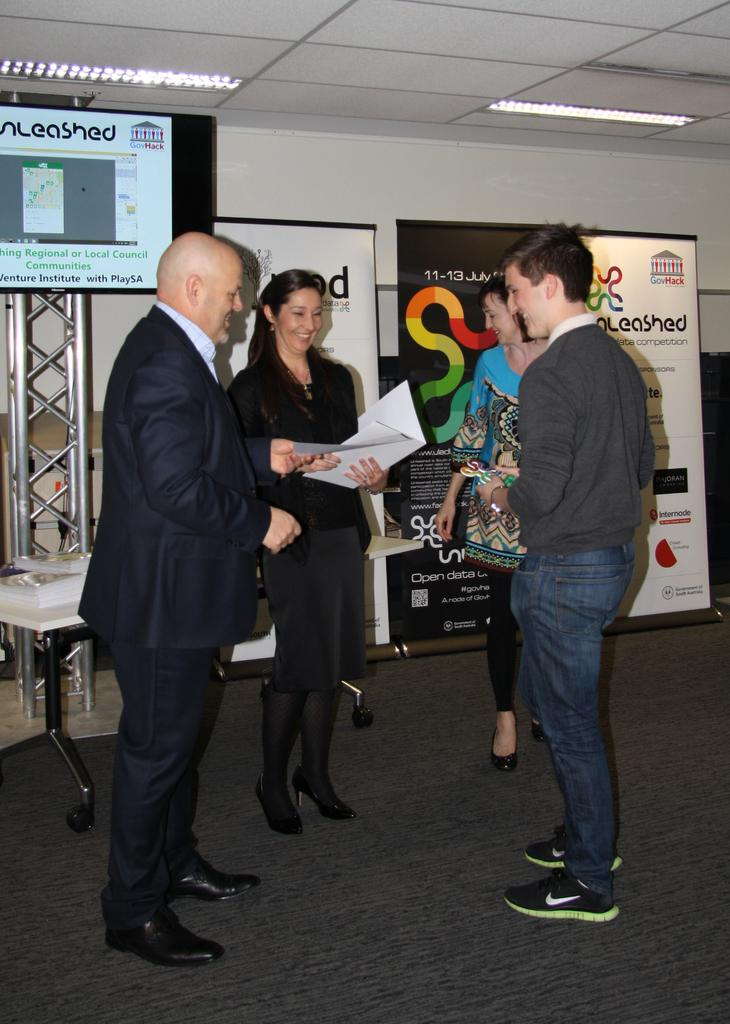How many people are present in the image? There are 4 people standing in the image. What are two of the people holding in their hands? Two of the people are holding papers in their hands. What type of furniture is present in the image? There is a table in the image. What decorative elements can be seen in the image? There are banners visible in the image. What is located at the top of the image? There are lights on the top of the image. What type of impulse can be seen affecting the people in the image? There is no impulse affecting the people in the image; they are standing still. Can you see a crown on any of the people's heads in the image? No, there is no crown present on any of the people's heads in the image. 